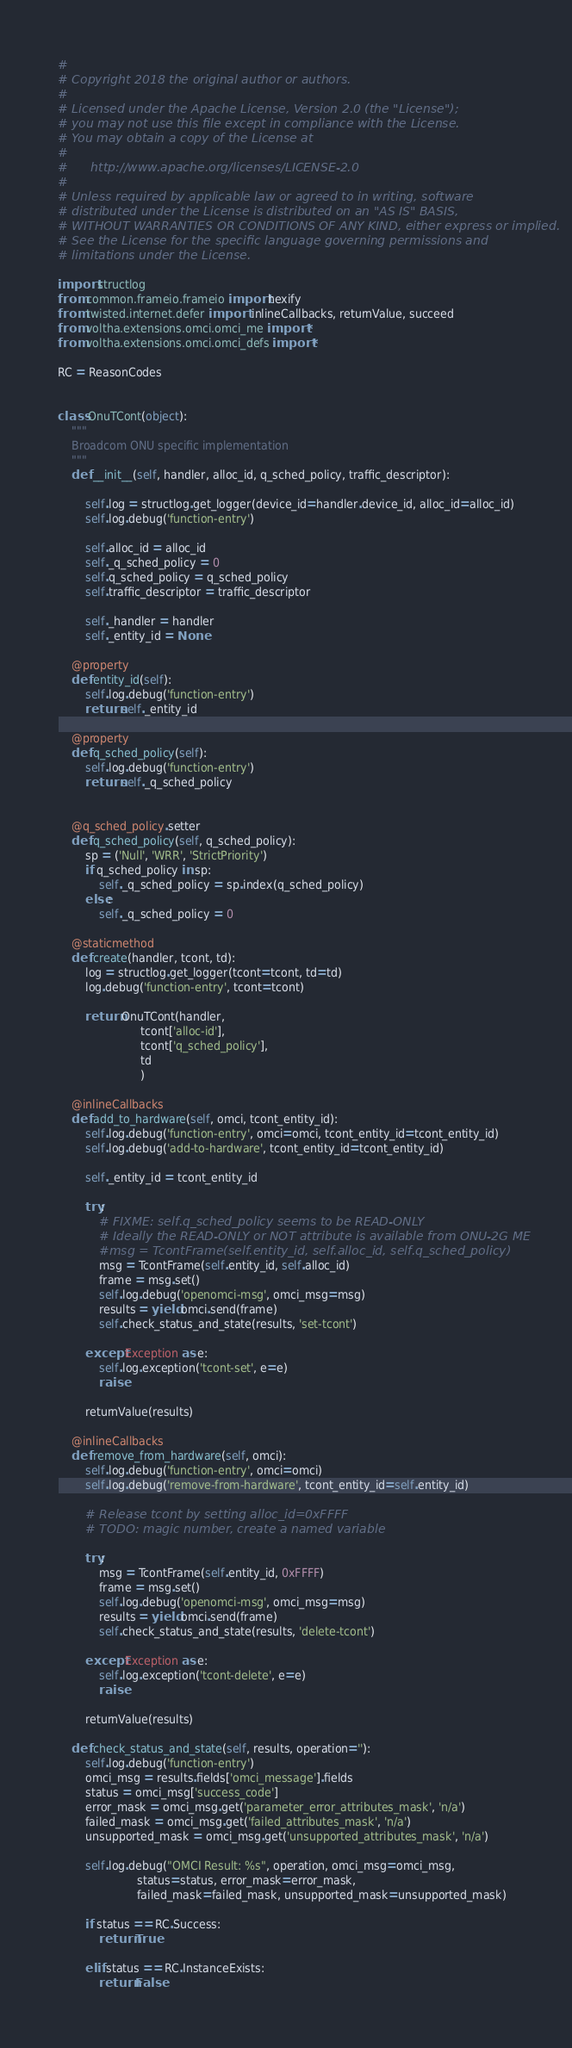<code> <loc_0><loc_0><loc_500><loc_500><_Python_>#
# Copyright 2018 the original author or authors.
#
# Licensed under the Apache License, Version 2.0 (the "License");
# you may not use this file except in compliance with the License.
# You may obtain a copy of the License at
#
#      http://www.apache.org/licenses/LICENSE-2.0
#
# Unless required by applicable law or agreed to in writing, software
# distributed under the License is distributed on an "AS IS" BASIS,
# WITHOUT WARRANTIES OR CONDITIONS OF ANY KIND, either express or implied.
# See the License for the specific language governing permissions and
# limitations under the License.

import structlog
from common.frameio.frameio import hexify
from twisted.internet.defer import  inlineCallbacks, returnValue, succeed
from voltha.extensions.omci.omci_me import *
from voltha.extensions.omci.omci_defs import *

RC = ReasonCodes


class OnuTCont(object):
    """
    Broadcom ONU specific implementation
    """
    def __init__(self, handler, alloc_id, q_sched_policy, traffic_descriptor):

        self.log = structlog.get_logger(device_id=handler.device_id, alloc_id=alloc_id)
        self.log.debug('function-entry')

        self.alloc_id = alloc_id
        self._q_sched_policy = 0
        self.q_sched_policy = q_sched_policy
        self.traffic_descriptor = traffic_descriptor

        self._handler = handler
        self._entity_id = None

    @property
    def entity_id(self):
        self.log.debug('function-entry')
        return self._entity_id

    @property
    def q_sched_policy(self):
        self.log.debug('function-entry')
        return self._q_sched_policy


    @q_sched_policy.setter
    def q_sched_policy(self, q_sched_policy):
        sp = ('Null', 'WRR', 'StrictPriority')
        if q_sched_policy in sp:
            self._q_sched_policy = sp.index(q_sched_policy)
        else:
            self._q_sched_policy = 0

    @staticmethod
    def create(handler, tcont, td):
        log = structlog.get_logger(tcont=tcont, td=td)
        log.debug('function-entry', tcont=tcont)

        return OnuTCont(handler,
                        tcont['alloc-id'],
                        tcont['q_sched_policy'],
                        td
                        )

    @inlineCallbacks
    def add_to_hardware(self, omci, tcont_entity_id):
        self.log.debug('function-entry', omci=omci, tcont_entity_id=tcont_entity_id)
        self.log.debug('add-to-hardware', tcont_entity_id=tcont_entity_id)

        self._entity_id = tcont_entity_id

        try:
            # FIXME: self.q_sched_policy seems to be READ-ONLY
            # Ideally the READ-ONLY or NOT attribute is available from ONU-2G ME
            #msg = TcontFrame(self.entity_id, self.alloc_id, self.q_sched_policy)
            msg = TcontFrame(self.entity_id, self.alloc_id)
            frame = msg.set()
            self.log.debug('openomci-msg', omci_msg=msg)
            results = yield omci.send(frame)
            self.check_status_and_state(results, 'set-tcont')

        except Exception as e:
            self.log.exception('tcont-set', e=e)
            raise

        returnValue(results)

    @inlineCallbacks
    def remove_from_hardware(self, omci):
        self.log.debug('function-entry', omci=omci)
        self.log.debug('remove-from-hardware', tcont_entity_id=self.entity_id)

        # Release tcont by setting alloc_id=0xFFFF
        # TODO: magic number, create a named variable

        try:
            msg = TcontFrame(self.entity_id, 0xFFFF)
            frame = msg.set()
            self.log.debug('openomci-msg', omci_msg=msg)
            results = yield omci.send(frame)
            self.check_status_and_state(results, 'delete-tcont')

        except Exception as e:
            self.log.exception('tcont-delete', e=e)
            raise

        returnValue(results)

    def check_status_and_state(self, results, operation=''):
        self.log.debug('function-entry')
        omci_msg = results.fields['omci_message'].fields
        status = omci_msg['success_code']
        error_mask = omci_msg.get('parameter_error_attributes_mask', 'n/a')
        failed_mask = omci_msg.get('failed_attributes_mask', 'n/a')
        unsupported_mask = omci_msg.get('unsupported_attributes_mask', 'n/a')

        self.log.debug("OMCI Result: %s", operation, omci_msg=omci_msg,
                       status=status, error_mask=error_mask,
                       failed_mask=failed_mask, unsupported_mask=unsupported_mask)

        if status == RC.Success:
            return True

        elif status == RC.InstanceExists:
            return False
</code> 